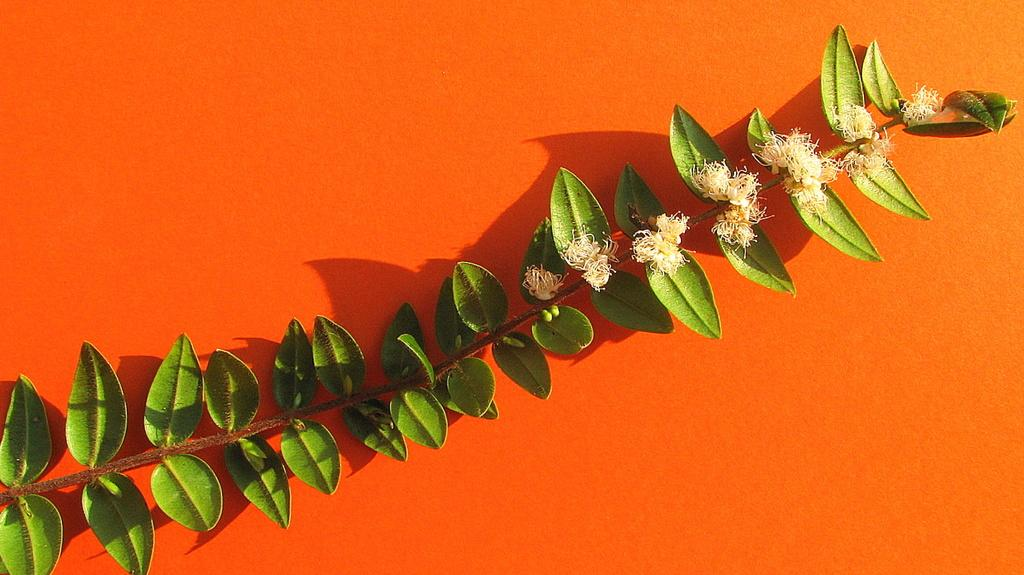What is the main subject of the image? The main subject of the image is a branch of a tree. What is the branch resting on in the image? The branch is on an orange surface. What can be seen on the branch? There are flowers blooming on the branch. How many pins are holding the branch in place in the image? There are no pins present in the image; the branch is resting on an orange surface. Can you see a kiss between the flowers in the image? There is no kiss depicted between the flowers in the image; it simply shows flowers blooming on the branch. 